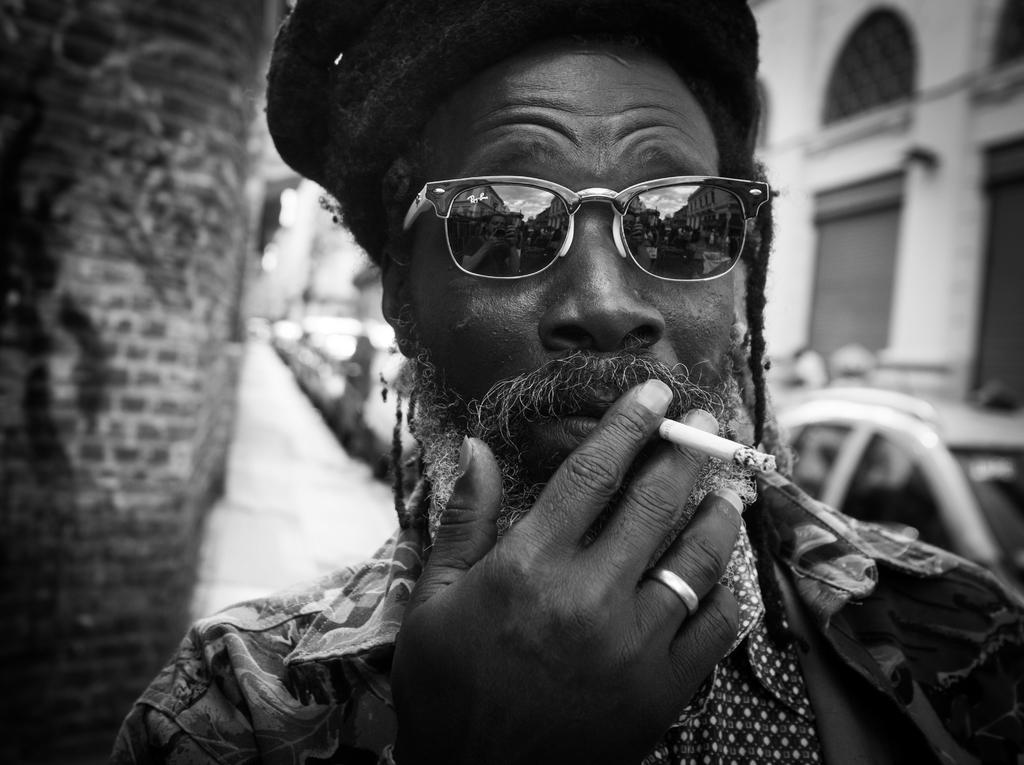What is the color scheme of the image? The image is black and white. What activity is the person in the image engaged in? The person is smoking in the image. What can be seen on the road in the image? There are vehicles on the road in the image. What structure is located on the right side of the image? There is a building on the right side of the image. Who is offering expert advice in the lunchroom in the image? There is no lunchroom or expert advice being offered in the image; it is a black and white image featuring a person smoking, vehicles on the road, and a building on the right side. 